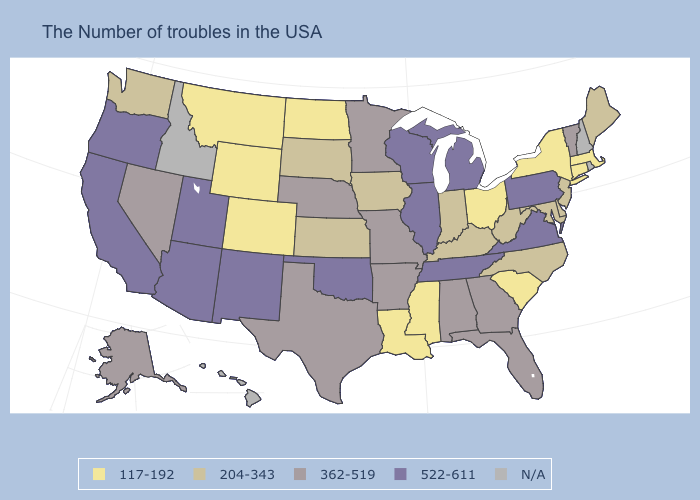Among the states that border Georgia , does South Carolina have the lowest value?
Give a very brief answer. Yes. Which states have the highest value in the USA?
Short answer required. Pennsylvania, Virginia, Michigan, Tennessee, Wisconsin, Illinois, Oklahoma, New Mexico, Utah, Arizona, California, Oregon. Name the states that have a value in the range 362-519?
Keep it brief. Vermont, Florida, Georgia, Alabama, Missouri, Arkansas, Minnesota, Nebraska, Texas, Nevada, Alaska. Name the states that have a value in the range 204-343?
Concise answer only. Maine, New Jersey, Delaware, Maryland, North Carolina, West Virginia, Kentucky, Indiana, Iowa, Kansas, South Dakota, Washington. Does South Carolina have the lowest value in the South?
Write a very short answer. Yes. How many symbols are there in the legend?
Write a very short answer. 5. How many symbols are there in the legend?
Keep it brief. 5. Does the first symbol in the legend represent the smallest category?
Quick response, please. Yes. What is the value of Kansas?
Give a very brief answer. 204-343. How many symbols are there in the legend?
Concise answer only. 5. Which states have the highest value in the USA?
Keep it brief. Pennsylvania, Virginia, Michigan, Tennessee, Wisconsin, Illinois, Oklahoma, New Mexico, Utah, Arizona, California, Oregon. Name the states that have a value in the range 362-519?
Answer briefly. Vermont, Florida, Georgia, Alabama, Missouri, Arkansas, Minnesota, Nebraska, Texas, Nevada, Alaska. Does the map have missing data?
Answer briefly. Yes. What is the highest value in the USA?
Be succinct. 522-611. What is the highest value in the USA?
Give a very brief answer. 522-611. 